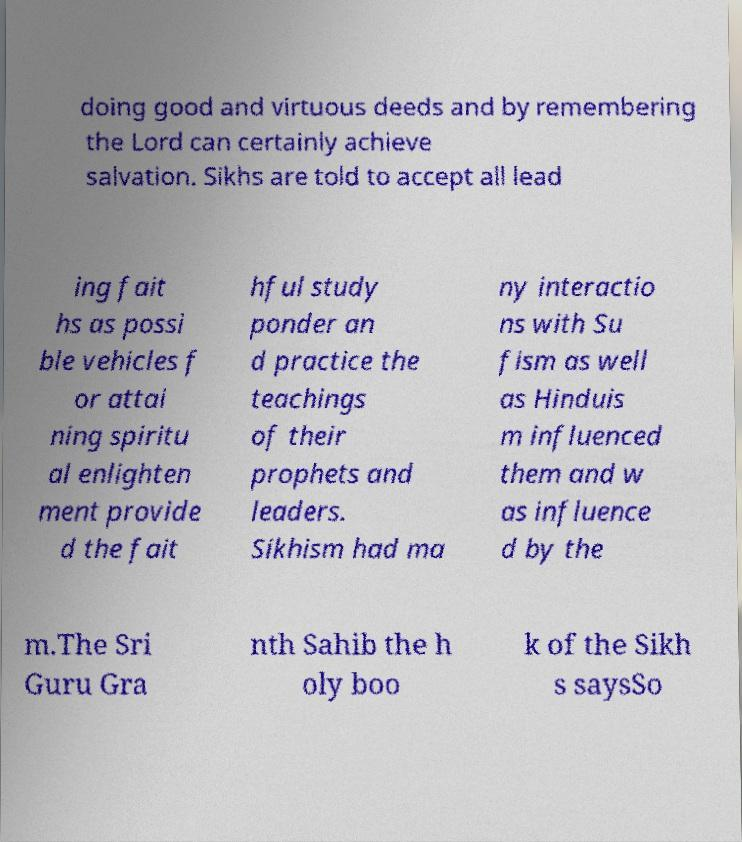Could you extract and type out the text from this image? doing good and virtuous deeds and by remembering the Lord can certainly achieve salvation. Sikhs are told to accept all lead ing fait hs as possi ble vehicles f or attai ning spiritu al enlighten ment provide d the fait hful study ponder an d practice the teachings of their prophets and leaders. Sikhism had ma ny interactio ns with Su fism as well as Hinduis m influenced them and w as influence d by the m.The Sri Guru Gra nth Sahib the h oly boo k of the Sikh s saysSo 